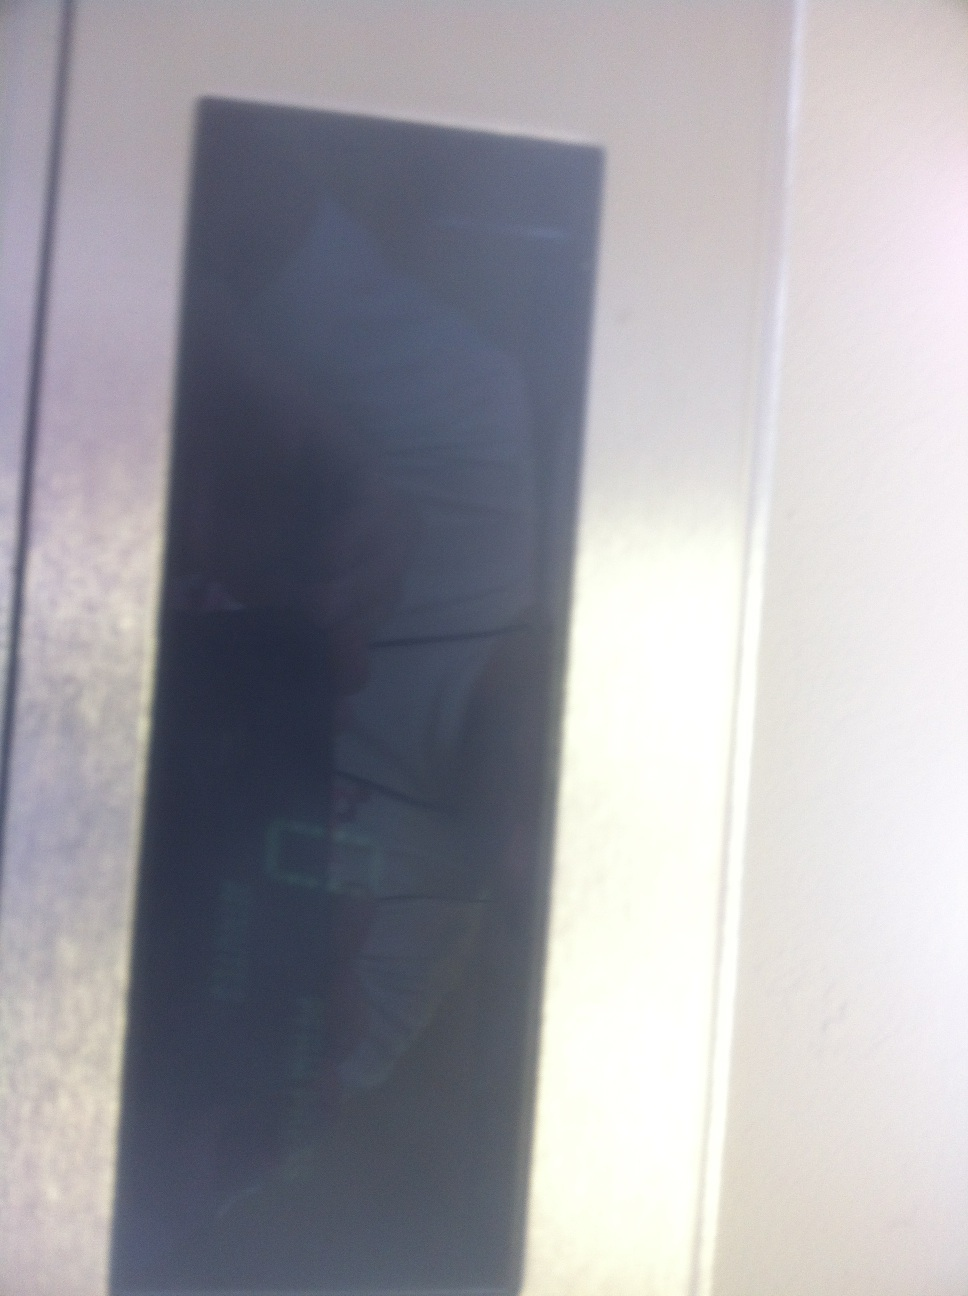Describe a scenario where this display malfunctions during critical operation. Imagine you're in an elevator in a high-rise building during peak hours. As people pile in and the elevator starts moving, the display suddenly glitches, showing distorted numbers and symbols. This malfunction causes confusion about the current floor and direction, leading to panic and delays. Technicians are urgently called to fix the issue, but until then, the elevator operates blindly, causing frustration and inconvenience to the building's occupants. 